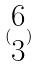Convert formula to latex. <formula><loc_0><loc_0><loc_500><loc_500>( \begin{matrix} 6 \\ 3 \end{matrix} )</formula> 